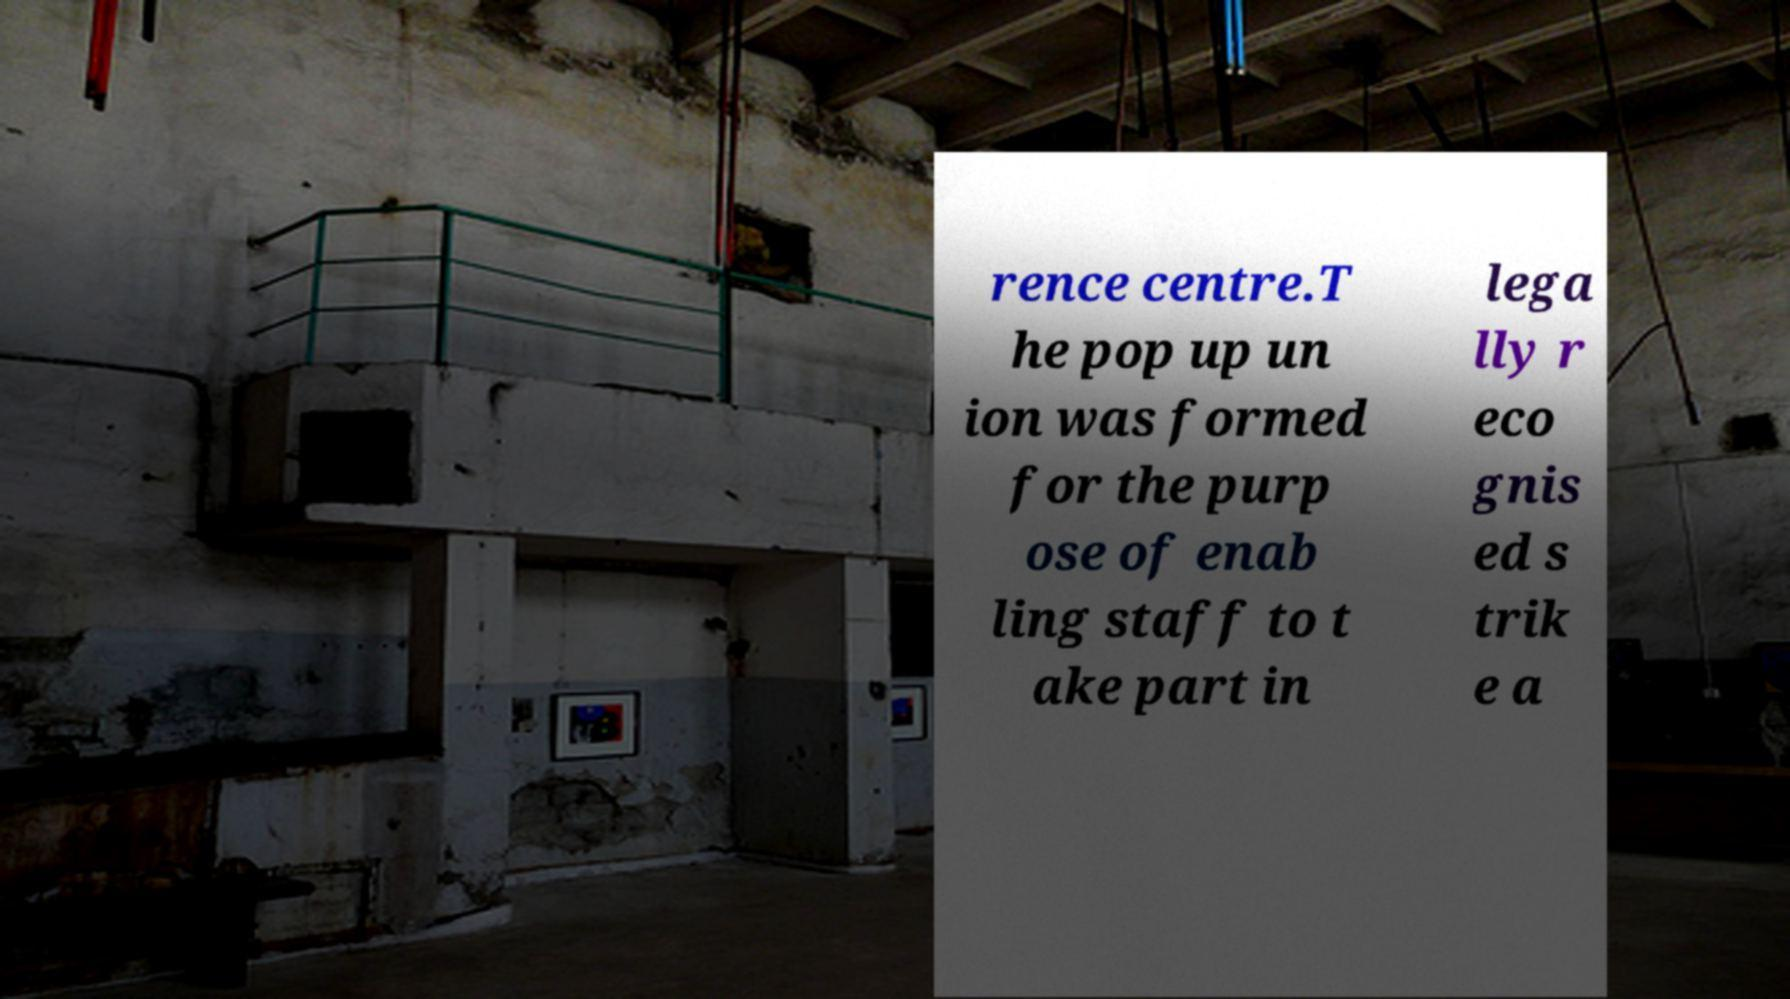For documentation purposes, I need the text within this image transcribed. Could you provide that? rence centre.T he pop up un ion was formed for the purp ose of enab ling staff to t ake part in lega lly r eco gnis ed s trik e a 